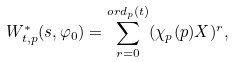<formula> <loc_0><loc_0><loc_500><loc_500>W ^ { * } _ { t , p } ( s , \varphi _ { 0 } ) = \sum _ { r = 0 } ^ { o r d _ { p } ( t ) } ( \chi _ { p } ( p ) X ) ^ { r } ,</formula> 